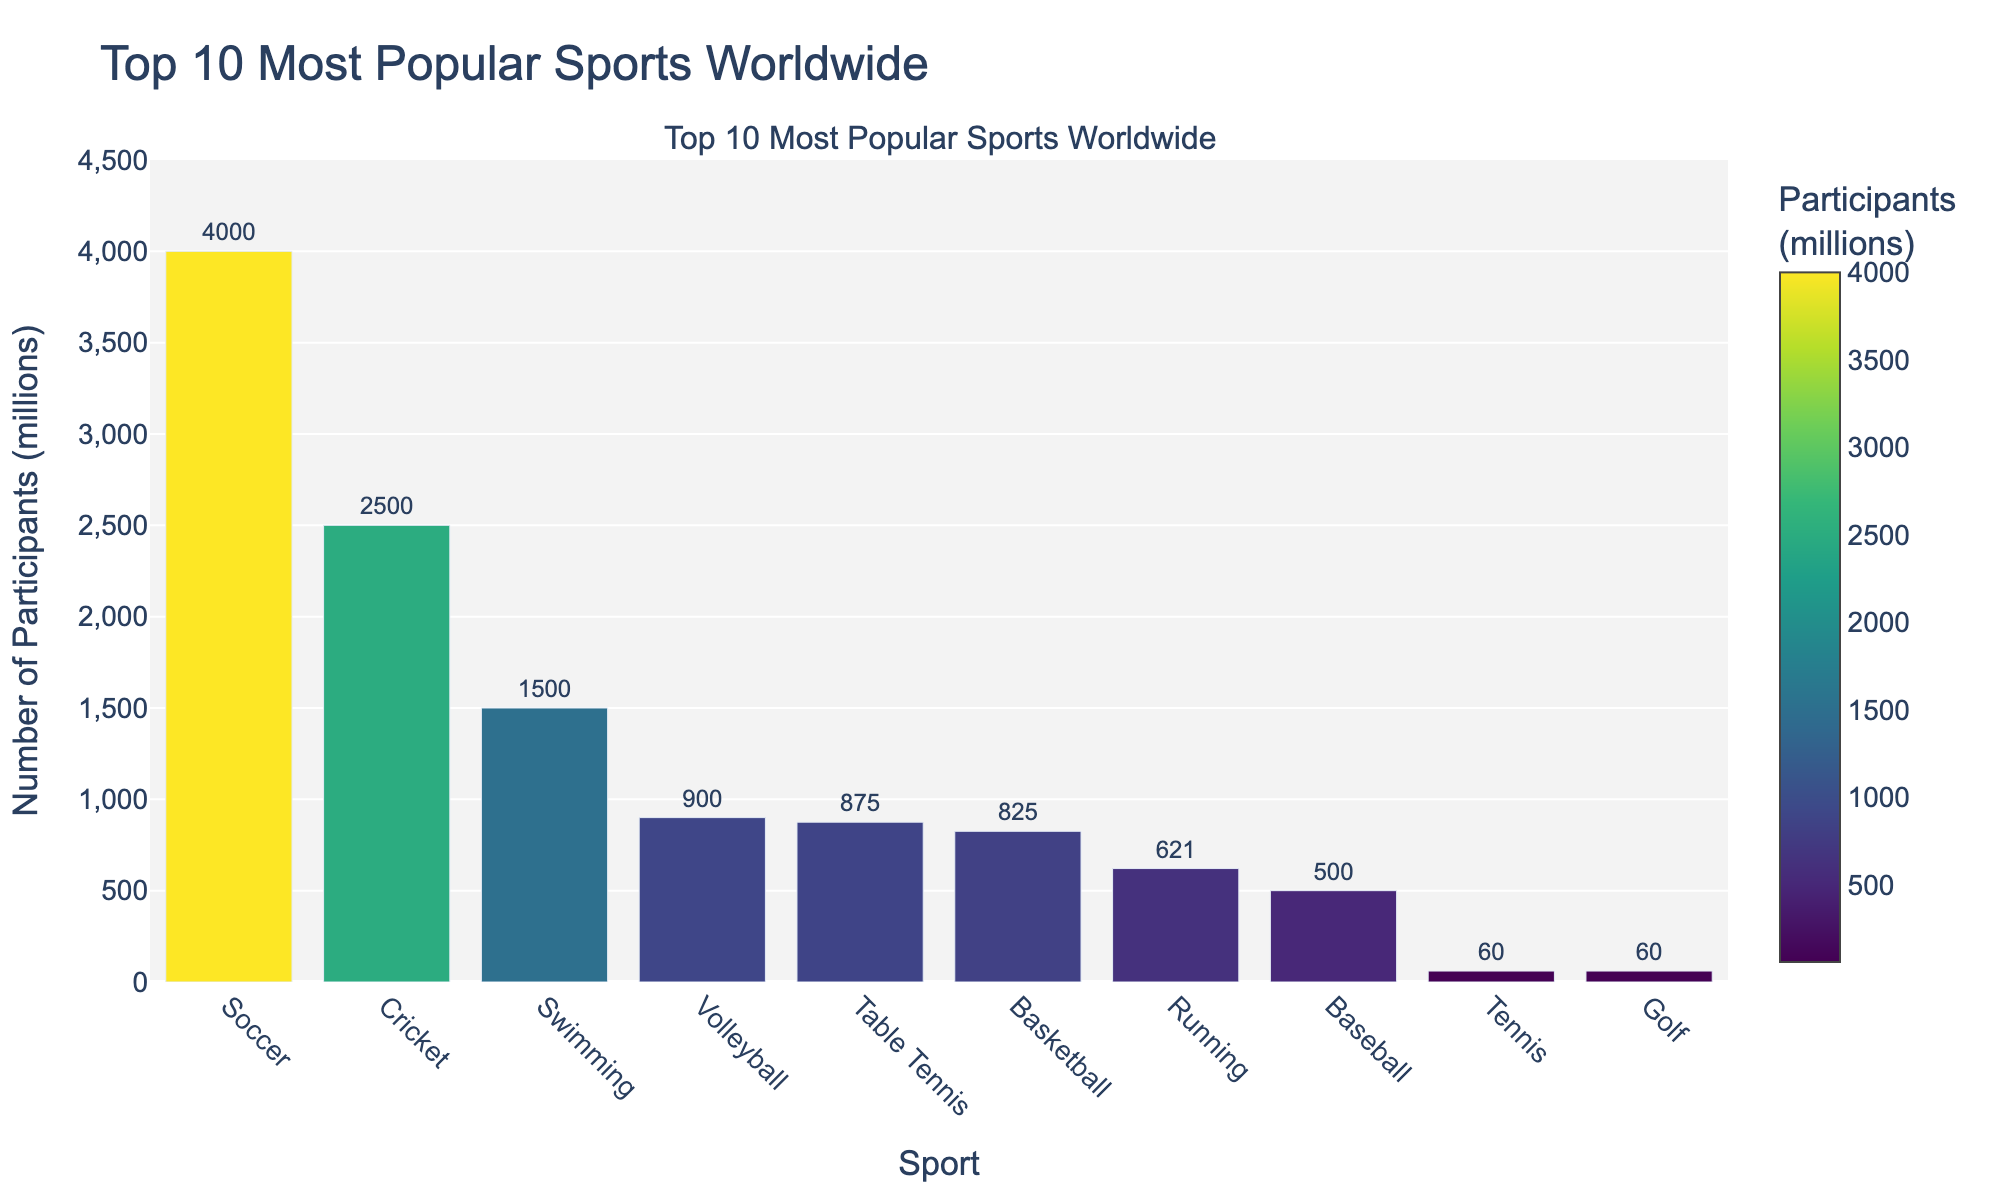Which sport has the highest number of participants? Soccer has the highest bar in the chart with the visual height far exceeding other bars, and it shows 4000 million participants.
Answer: Soccer How many more participants does Soccer have compared to Basketball? Soccer has 4000 million participants and Basketball has 825 million participants. Subtracting the two gives us 4000 - 825 = 3175 million.
Answer: 3175 million Which sport has fewer participants, Tennis or Golf? Tennis's bar is annotated with 60 million participants, as is Golf's bar. However, the annotations reveal that both sports have the same number of participants (60 million).
Answer: Both have the same Is Cricket more popular than Baseball? Cricket’s bar representing 2500 million participants is significantly higher than Baseball’s bar, which represents 500 million participants.
Answer: Yes What's the sum of participants for Soccer, Cricket, and Swimming combined? The number of participants for Soccer, Cricket, and Swimming are 4000, 2500, and 1500 million respectively. Adding them up gives 4000 + 2500 + 1500 = 8000 million.
Answer: 8000 million Which sport has the smallest number of participants and how many? Both Tennis and Golf have the smallest bar heights, both annotated with 60 million participants.
Answer: Tennis and Golf, 60 million each How many sports have over 1000 million participants? From the bar heights and annotations, only Soccer (4000 million), Cricket (2500 million), and Swimming (1500 million) exceed 1000 million participants. This makes three sports.
Answer: Three By how much does the number of Volleyball participants exceed Running participants? Volleyball has 900 million participants while Running has 621 million participants. Subtracting the two gives 900 - 621 = 279 million.
Answer: 279 million What is the range of participant numbers among the sports listed? The minimum number of participants is 60 million (both Tennis and Golf) and the maximum is 4000 million (Soccer). The range is 4000 - 60 = 3940 million.
Answer: 3940 million Which sport has approximately the same number of participants as Swimming? Cricket's bar is somewhat close to Swimming's in height visually, with Swimming having 1500 million and Cricket having 2500 million. However, Table Tennis with 875 million is closer than Cricket.
Answer: Cricket is not close, Table Tennis is closer 